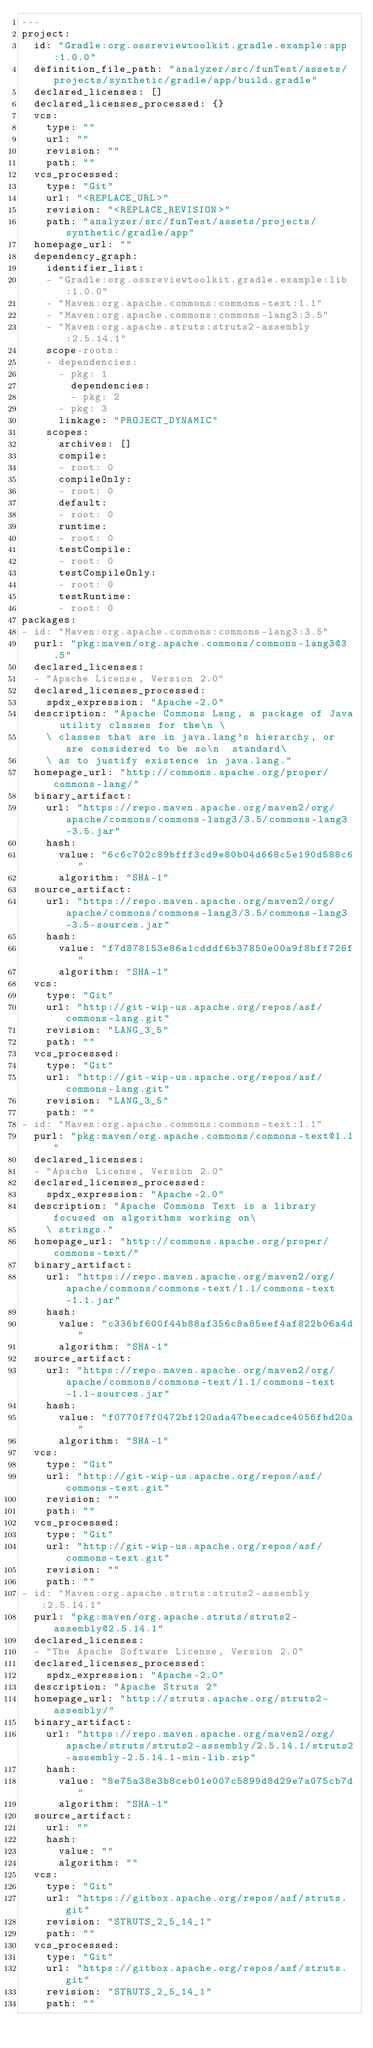<code> <loc_0><loc_0><loc_500><loc_500><_YAML_>---
project:
  id: "Gradle:org.ossreviewtoolkit.gradle.example:app:1.0.0"
  definition_file_path: "analyzer/src/funTest/assets/projects/synthetic/gradle/app/build.gradle"
  declared_licenses: []
  declared_licenses_processed: {}
  vcs:
    type: ""
    url: ""
    revision: ""
    path: ""
  vcs_processed:
    type: "Git"
    url: "<REPLACE_URL>"
    revision: "<REPLACE_REVISION>"
    path: "analyzer/src/funTest/assets/projects/synthetic/gradle/app"
  homepage_url: ""
  dependency_graph:
    identifier_list:
    - "Gradle:org.ossreviewtoolkit.gradle.example:lib:1.0.0"
    - "Maven:org.apache.commons:commons-text:1.1"
    - "Maven:org.apache.commons:commons-lang3:3.5"
    - "Maven:org.apache.struts:struts2-assembly:2.5.14.1"
    scope-roots:
    - dependencies:
      - pkg: 1
        dependencies:
        - pkg: 2
      - pkg: 3
      linkage: "PROJECT_DYNAMIC"
    scopes:
      archives: []
      compile:
      - root: 0
      compileOnly:
      - root: 0
      default:
      - root: 0
      runtime:
      - root: 0
      testCompile:
      - root: 0
      testCompileOnly:
      - root: 0
      testRuntime:
      - root: 0
packages:
- id: "Maven:org.apache.commons:commons-lang3:3.5"
  purl: "pkg:maven/org.apache.commons/commons-lang3@3.5"
  declared_licenses:
  - "Apache License, Version 2.0"
  declared_licenses_processed:
    spdx_expression: "Apache-2.0"
  description: "Apache Commons Lang, a package of Java utility classes for the\n \
    \ classes that are in java.lang's hierarchy, or are considered to be so\n  standard\
    \ as to justify existence in java.lang."
  homepage_url: "http://commons.apache.org/proper/commons-lang/"
  binary_artifact:
    url: "https://repo.maven.apache.org/maven2/org/apache/commons/commons-lang3/3.5/commons-lang3-3.5.jar"
    hash:
      value: "6c6c702c89bfff3cd9e80b04d668c5e190d588c6"
      algorithm: "SHA-1"
  source_artifact:
    url: "https://repo.maven.apache.org/maven2/org/apache/commons/commons-lang3/3.5/commons-lang3-3.5-sources.jar"
    hash:
      value: "f7d878153e86a1cdddf6b37850e00a9f8bff726f"
      algorithm: "SHA-1"
  vcs:
    type: "Git"
    url: "http://git-wip-us.apache.org/repos/asf/commons-lang.git"
    revision: "LANG_3_5"
    path: ""
  vcs_processed:
    type: "Git"
    url: "http://git-wip-us.apache.org/repos/asf/commons-lang.git"
    revision: "LANG_3_5"
    path: ""
- id: "Maven:org.apache.commons:commons-text:1.1"
  purl: "pkg:maven/org.apache.commons/commons-text@1.1"
  declared_licenses:
  - "Apache License, Version 2.0"
  declared_licenses_processed:
    spdx_expression: "Apache-2.0"
  description: "Apache Commons Text is a library focused on algorithms working on\
    \ strings."
  homepage_url: "http://commons.apache.org/proper/commons-text/"
  binary_artifact:
    url: "https://repo.maven.apache.org/maven2/org/apache/commons/commons-text/1.1/commons-text-1.1.jar"
    hash:
      value: "c336bf600f44b88af356c8a85eef4af822b06a4d"
      algorithm: "SHA-1"
  source_artifact:
    url: "https://repo.maven.apache.org/maven2/org/apache/commons/commons-text/1.1/commons-text-1.1-sources.jar"
    hash:
      value: "f0770f7f0472bf120ada47beecadce4056fbd20a"
      algorithm: "SHA-1"
  vcs:
    type: "Git"
    url: "http://git-wip-us.apache.org/repos/asf/commons-text.git"
    revision: ""
    path: ""
  vcs_processed:
    type: "Git"
    url: "http://git-wip-us.apache.org/repos/asf/commons-text.git"
    revision: ""
    path: ""
- id: "Maven:org.apache.struts:struts2-assembly:2.5.14.1"
  purl: "pkg:maven/org.apache.struts/struts2-assembly@2.5.14.1"
  declared_licenses:
  - "The Apache Software License, Version 2.0"
  declared_licenses_processed:
    spdx_expression: "Apache-2.0"
  description: "Apache Struts 2"
  homepage_url: "http://struts.apache.org/struts2-assembly/"
  binary_artifact:
    url: "https://repo.maven.apache.org/maven2/org/apache/struts/struts2-assembly/2.5.14.1/struts2-assembly-2.5.14.1-min-lib.zip"
    hash:
      value: "8e75a38e3b8ceb01e007c5899d8d29e7a075cb7d"
      algorithm: "SHA-1"
  source_artifact:
    url: ""
    hash:
      value: ""
      algorithm: ""
  vcs:
    type: "Git"
    url: "https://gitbox.apache.org/repos/asf/struts.git"
    revision: "STRUTS_2_5_14_1"
    path: ""
  vcs_processed:
    type: "Git"
    url: "https://gitbox.apache.org/repos/asf/struts.git"
    revision: "STRUTS_2_5_14_1"
    path: ""
</code> 